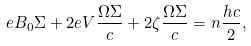Convert formula to latex. <formula><loc_0><loc_0><loc_500><loc_500>e B _ { 0 } \Sigma + 2 e V \frac { \Omega \Sigma } { c } + 2 \zeta \frac { \Omega \Sigma } { c } = n \frac { h c } { 2 } ,</formula> 